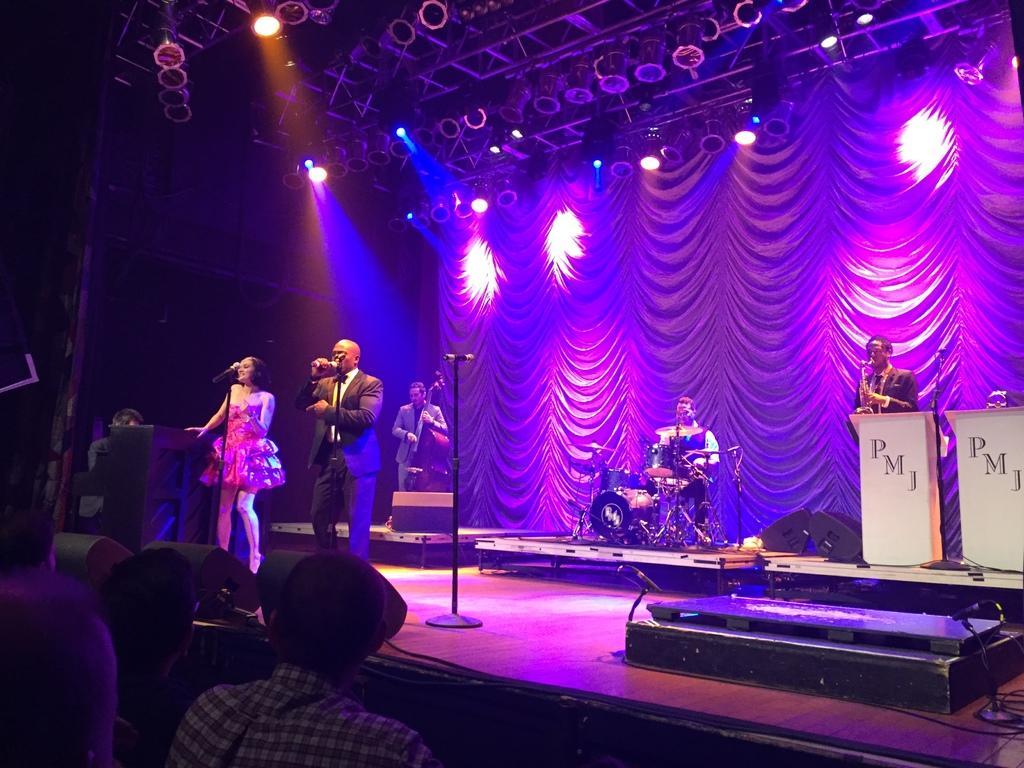Can you describe this image briefly? This looks like a stage show. I can see two people standing and singing a song. These are the mikes, which are attached to the mike stands. Here is a person playing the drums. I can see two people playing the musical instruments. I think these are the kind of the podiums. I can see the show lights, which are attached to the lighting truss´s. This looks like a curtain hanging. At the bottom of the image, I can see few people. 